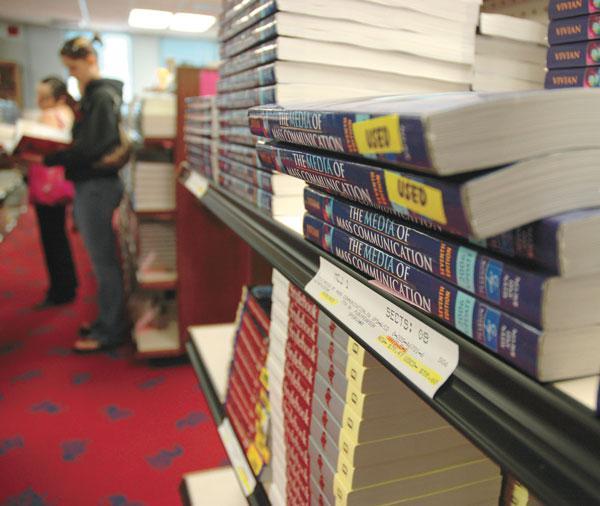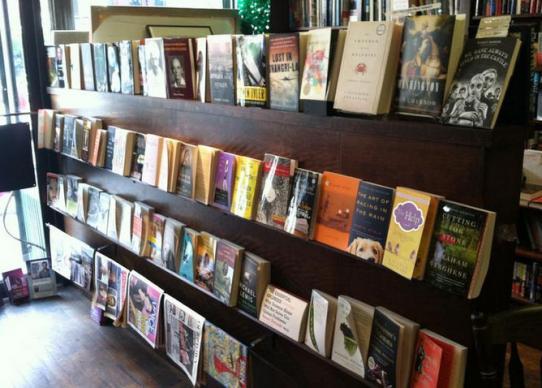The first image is the image on the left, the second image is the image on the right. Analyze the images presented: Is the assertion "Several of the books on the shelves have yellow stickers." valid? Answer yes or no. Yes. The first image is the image on the left, the second image is the image on the right. Given the left and right images, does the statement "In at least one image, books are stacked on their sides on shelves, some with yellow rectangles on their spines." hold true? Answer yes or no. Yes. 